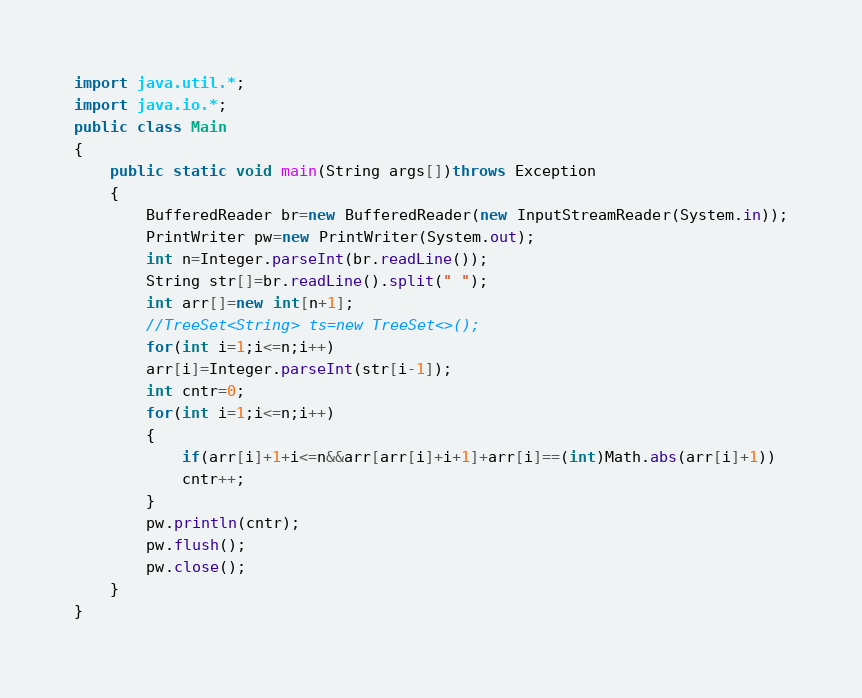<code> <loc_0><loc_0><loc_500><loc_500><_Java_>import java.util.*;
import java.io.*;
public class Main
{
    public static void main(String args[])throws Exception
    {
        BufferedReader br=new BufferedReader(new InputStreamReader(System.in));
        PrintWriter pw=new PrintWriter(System.out);
        int n=Integer.parseInt(br.readLine());
        String str[]=br.readLine().split(" ");
        int arr[]=new int[n+1];
        //TreeSet<String> ts=new TreeSet<>();
        for(int i=1;i<=n;i++)
        arr[i]=Integer.parseInt(str[i-1]);
        int cntr=0;
        for(int i=1;i<=n;i++)
        {
            if(arr[i]+1+i<=n&&arr[arr[i]+i+1]+arr[i]==(int)Math.abs(arr[i]+1))
            cntr++;
        }
        pw.println(cntr);
        pw.flush();
        pw.close();
    }
}</code> 